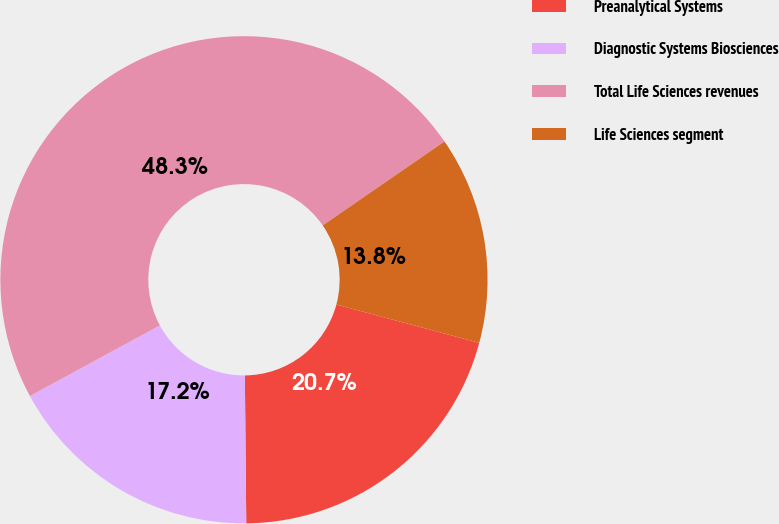<chart> <loc_0><loc_0><loc_500><loc_500><pie_chart><fcel>Preanalytical Systems<fcel>Diagnostic Systems Biosciences<fcel>Total Life Sciences revenues<fcel>Life Sciences segment<nl><fcel>20.68%<fcel>17.23%<fcel>48.31%<fcel>13.78%<nl></chart> 